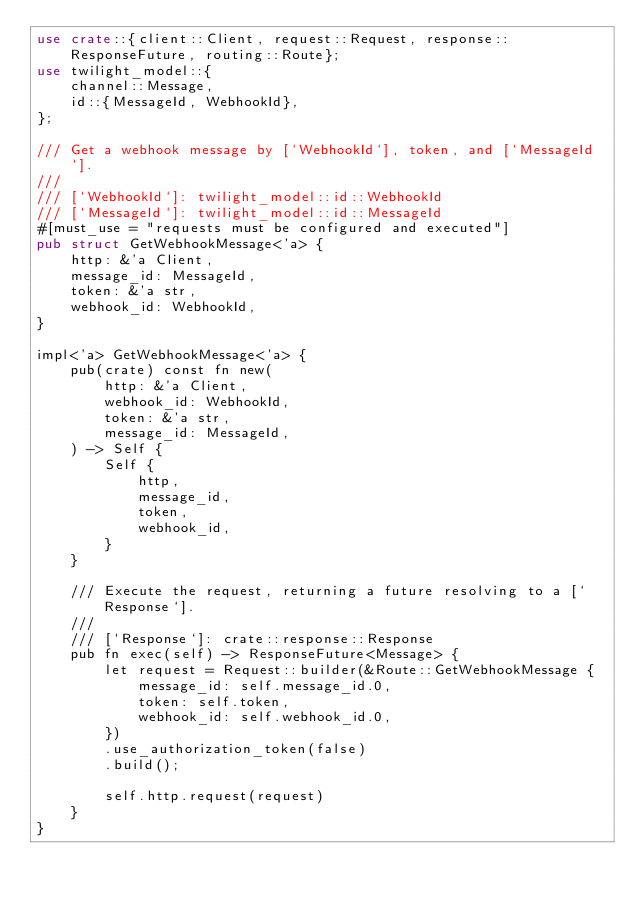<code> <loc_0><loc_0><loc_500><loc_500><_Rust_>use crate::{client::Client, request::Request, response::ResponseFuture, routing::Route};
use twilight_model::{
    channel::Message,
    id::{MessageId, WebhookId},
};

/// Get a webhook message by [`WebhookId`], token, and [`MessageId`].
///
/// [`WebhookId`]: twilight_model::id::WebhookId
/// [`MessageId`]: twilight_model::id::MessageId
#[must_use = "requests must be configured and executed"]
pub struct GetWebhookMessage<'a> {
    http: &'a Client,
    message_id: MessageId,
    token: &'a str,
    webhook_id: WebhookId,
}

impl<'a> GetWebhookMessage<'a> {
    pub(crate) const fn new(
        http: &'a Client,
        webhook_id: WebhookId,
        token: &'a str,
        message_id: MessageId,
    ) -> Self {
        Self {
            http,
            message_id,
            token,
            webhook_id,
        }
    }

    /// Execute the request, returning a future resolving to a [`Response`].
    ///
    /// [`Response`]: crate::response::Response
    pub fn exec(self) -> ResponseFuture<Message> {
        let request = Request::builder(&Route::GetWebhookMessage {
            message_id: self.message_id.0,
            token: self.token,
            webhook_id: self.webhook_id.0,
        })
        .use_authorization_token(false)
        .build();

        self.http.request(request)
    }
}
</code> 